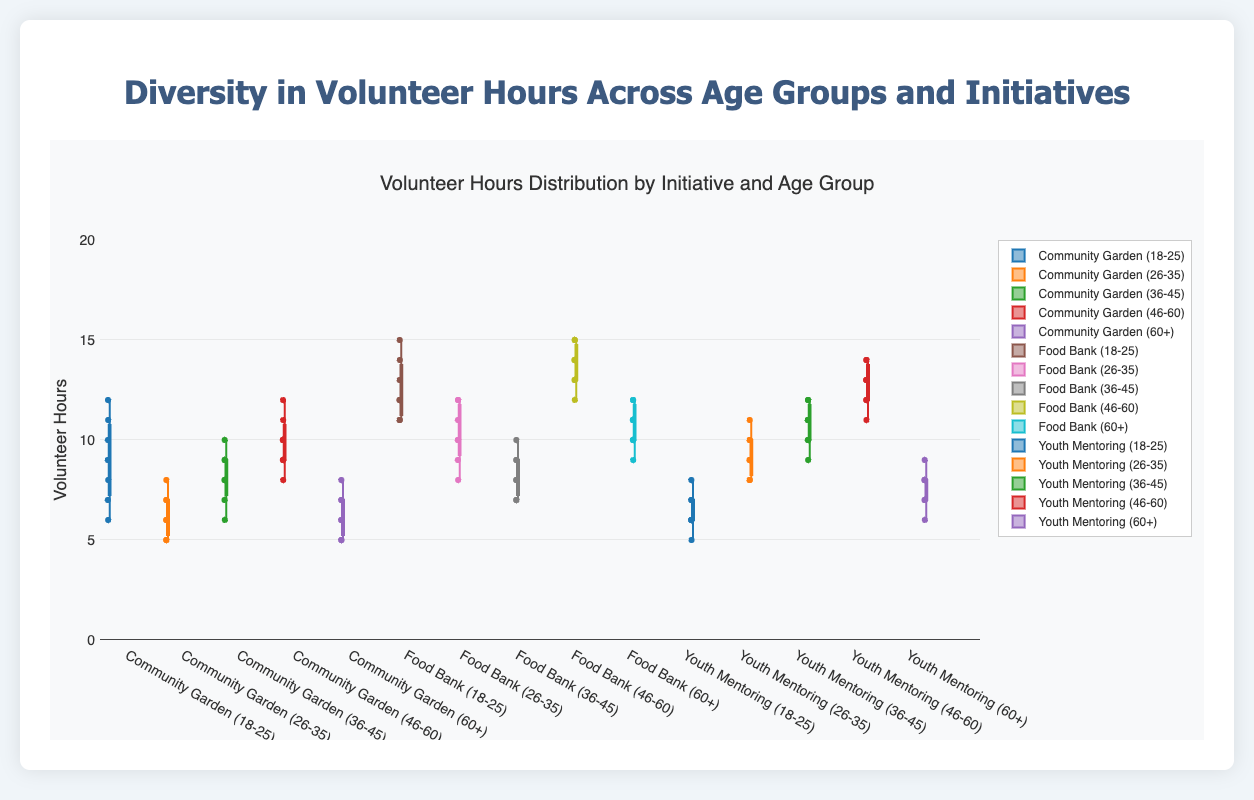What is the title of the figure? The title is usually displayed at the top of the figure, making it easy to identify.
Answer: Volunteer Hours Distribution by Initiative and Age Group Which age group contributed the most volunteer hours to the Food Bank? By examining the box plots for each age group under the "Food Bank" initiative, we can see that age group 46-60 has the highest median, upper quartile, and outliers.
Answer: 46-60 What is the median volunteer hour for the "Youth Mentoring" initiative among the "36-45" age group? The median is the line inside the box that divides it into two equal halves. For "Youth Mentoring" and "36-45," this line is at 11 hours.
Answer: 11 hours How do the volunteer hours of the "18-25" age group for the Community Garden initiative compare with the "60+" age group for the same initiative? By comparing the positions of the box plots, the "18-25" age group's median and interquartile range are higher than those for the "60+" age group.
Answer: Higher Which initiative has the widest range of volunteer hours for the "46-60" age group? The range is calculated by subtracting the minimum value (bottom whisker) from the maximum value (top whisker). The "Food Bank" initiative has the widest range for the "46-60" age group.
Answer: Food Bank What is the interquartile range (IQR) for the "26-35" age group in the Food Bank initiative? The IQR is the difference between the third quartile and the first quartile. For "26-35" in Food Bank, this is (12 - 9).
Answer: 3 Do any initiatives have outliers for the "60+" age group? If so, which? Outliers are points outside the whiskers of the box plots. The "Y-axis" has more dots beyond the whiskers for "Community Garden," "Food Bank," and "Youth Mentoring" for 60+ age.
Answer: Yes, Community Garden, Food Bank, and Youth Mentoring Compare the overall volunteer hours distribution between the "Community Garden" and "Youth Mentoring" initiatives. By examining the overall positions and spread of all age groups' box plots within these two initiatives, "Youth Mentoring" consistently displays higher medians and more outliers across the age groups compared to "Community Garden."
Answer: Youth Mentoring displays higher hours 